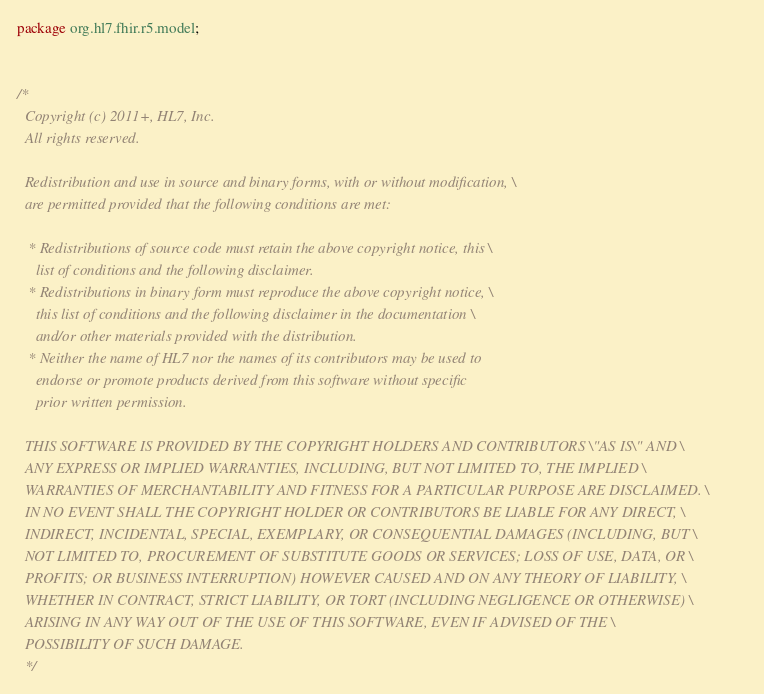Convert code to text. <code><loc_0><loc_0><loc_500><loc_500><_Java_>package org.hl7.fhir.r5.model;


/*
  Copyright (c) 2011+, HL7, Inc.
  All rights reserved.
  
  Redistribution and use in source and binary forms, with or without modification, \
  are permitted provided that the following conditions are met:
  
   * Redistributions of source code must retain the above copyright notice, this \
     list of conditions and the following disclaimer.
   * Redistributions in binary form must reproduce the above copyright notice, \
     this list of conditions and the following disclaimer in the documentation \
     and/or other materials provided with the distribution.
   * Neither the name of HL7 nor the names of its contributors may be used to 
     endorse or promote products derived from this software without specific 
     prior written permission.
  
  THIS SOFTWARE IS PROVIDED BY THE COPYRIGHT HOLDERS AND CONTRIBUTORS \"AS IS\" AND \
  ANY EXPRESS OR IMPLIED WARRANTIES, INCLUDING, BUT NOT LIMITED TO, THE IMPLIED \
  WARRANTIES OF MERCHANTABILITY AND FITNESS FOR A PARTICULAR PURPOSE ARE DISCLAIMED. \
  IN NO EVENT SHALL THE COPYRIGHT HOLDER OR CONTRIBUTORS BE LIABLE FOR ANY DIRECT, \
  INDIRECT, INCIDENTAL, SPECIAL, EXEMPLARY, OR CONSEQUENTIAL DAMAGES (INCLUDING, BUT \
  NOT LIMITED TO, PROCUREMENT OF SUBSTITUTE GOODS OR SERVICES; LOSS OF USE, DATA, OR \
  PROFITS; OR BUSINESS INTERRUPTION) HOWEVER CAUSED AND ON ANY THEORY OF LIABILITY, \
  WHETHER IN CONTRACT, STRICT LIABILITY, OR TORT (INCLUDING NEGLIGENCE OR OTHERWISE) \
  ARISING IN ANY WAY OUT OF THE USE OF THIS SOFTWARE, EVEN IF ADVISED OF THE \
  POSSIBILITY OF SUCH DAMAGE.
  */
</code> 